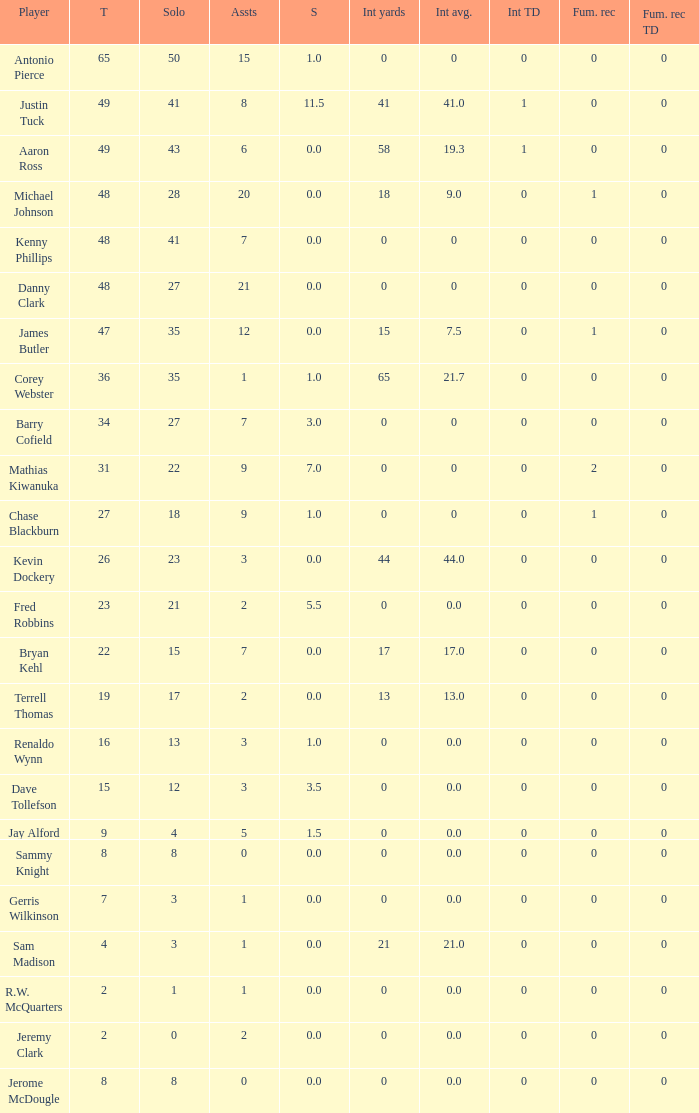What is the sum for the int yards that has an assts more than 3, and player Jay Alford? 0.0. 